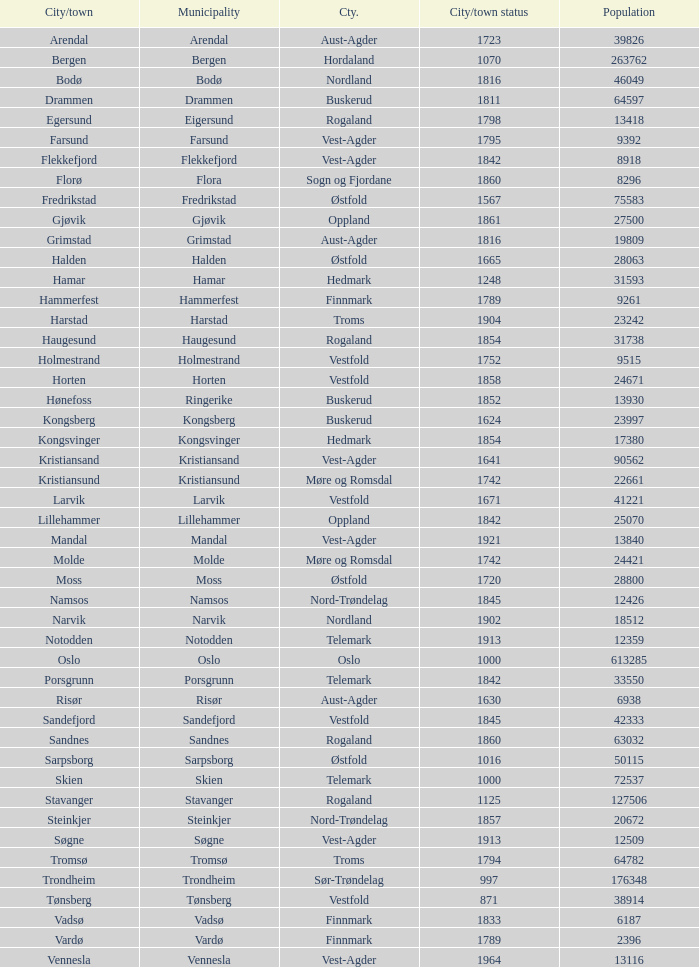What are the urban areas situated in the municipality of moss? Moss. 